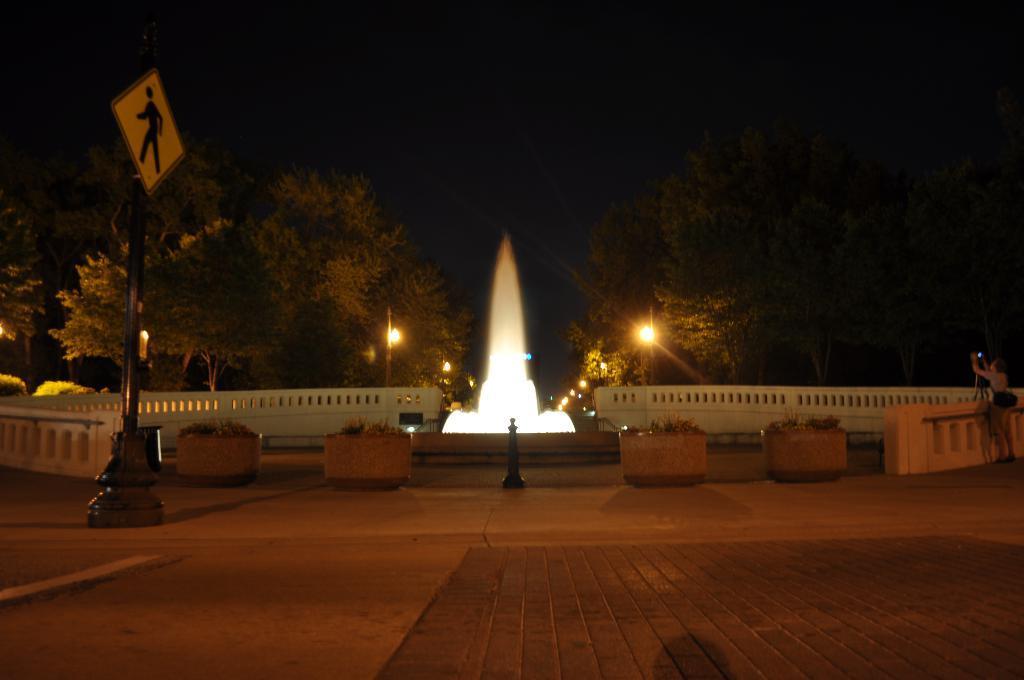Could you give a brief overview of what you see in this image? In this picture I can observe a fountain in the middle of the picture. On the left side I can observe a pole to which a board is fixed. In the background there are trees and sky which is completely dark. 